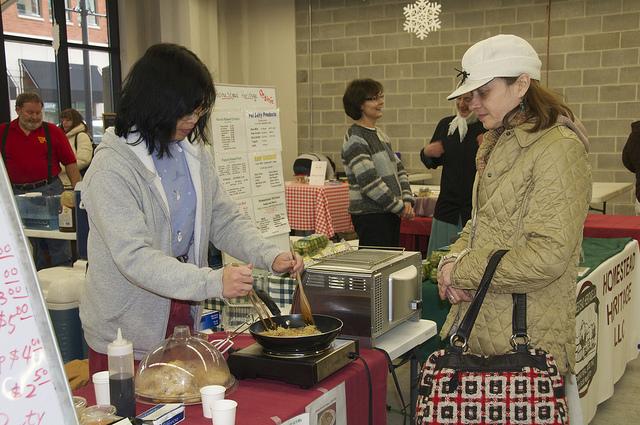Is the person cooking on a full size cooktop?
Write a very short answer. No. What type of music are they playing?
Keep it brief. None. What is on the wall?
Concise answer only. Snowflake. What is being cooked?
Write a very short answer. Eggs. Is this a commercial kitchen?
Be succinct. No. How many people are wearing red shirts?
Keep it brief. 1. 